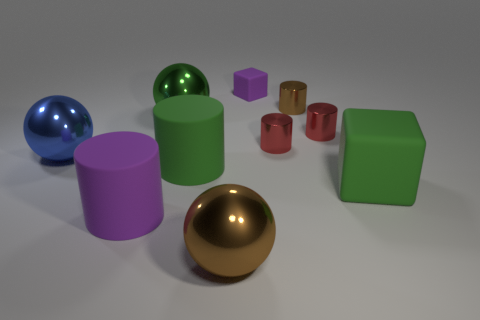How many brown objects are there?
Keep it short and to the point. 2. Do the brown sphere and the tiny brown object have the same material?
Ensure brevity in your answer.  Yes. Is the size of the cube that is in front of the tiny brown cylinder the same as the purple matte thing left of the small matte block?
Provide a short and direct response. Yes. Is the number of large green rubber objects less than the number of metal objects?
Keep it short and to the point. Yes. How many metal objects are tiny blue things or spheres?
Keep it short and to the point. 3. Is there a green matte cylinder on the left side of the large rubber object that is in front of the green cube?
Provide a short and direct response. No. Are the brown thing in front of the big purple cylinder and the tiny brown object made of the same material?
Provide a short and direct response. Yes. What number of other things are there of the same color as the tiny cube?
Make the answer very short. 1. What is the size of the brown metallic object that is right of the ball that is in front of the large purple rubber thing?
Give a very brief answer. Small. Is the material of the brown object that is in front of the purple matte cylinder the same as the green thing that is on the right side of the brown cylinder?
Ensure brevity in your answer.  No. 